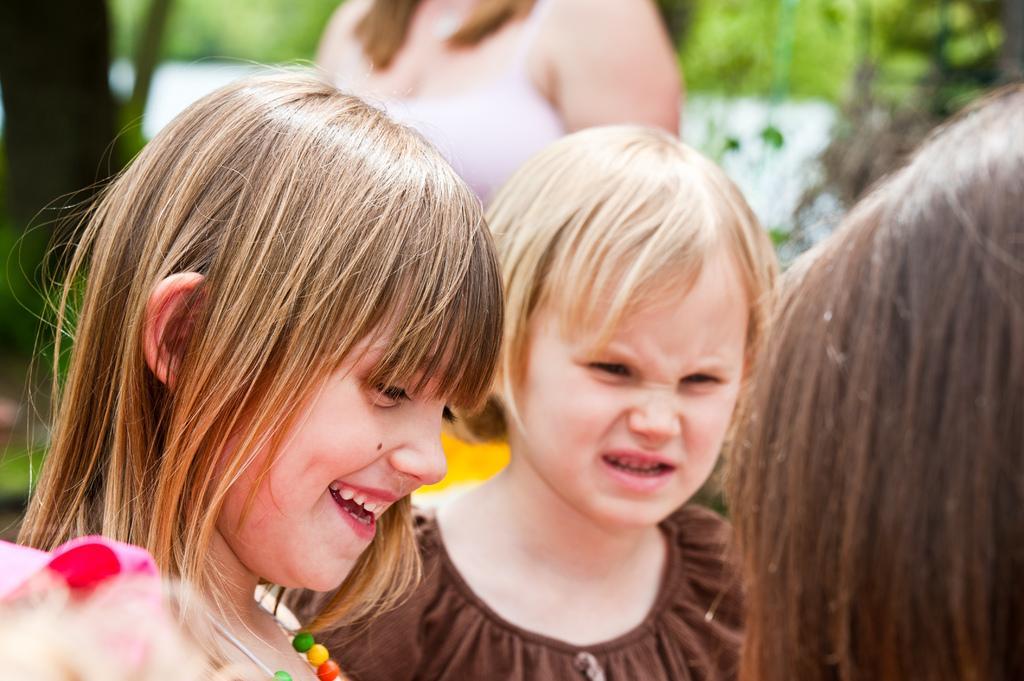In one or two sentences, can you explain what this image depicts? In the image we can see there are children wearing clothes. The left side girl is wearing a neck chain and she is smiling. The background is blurred. 